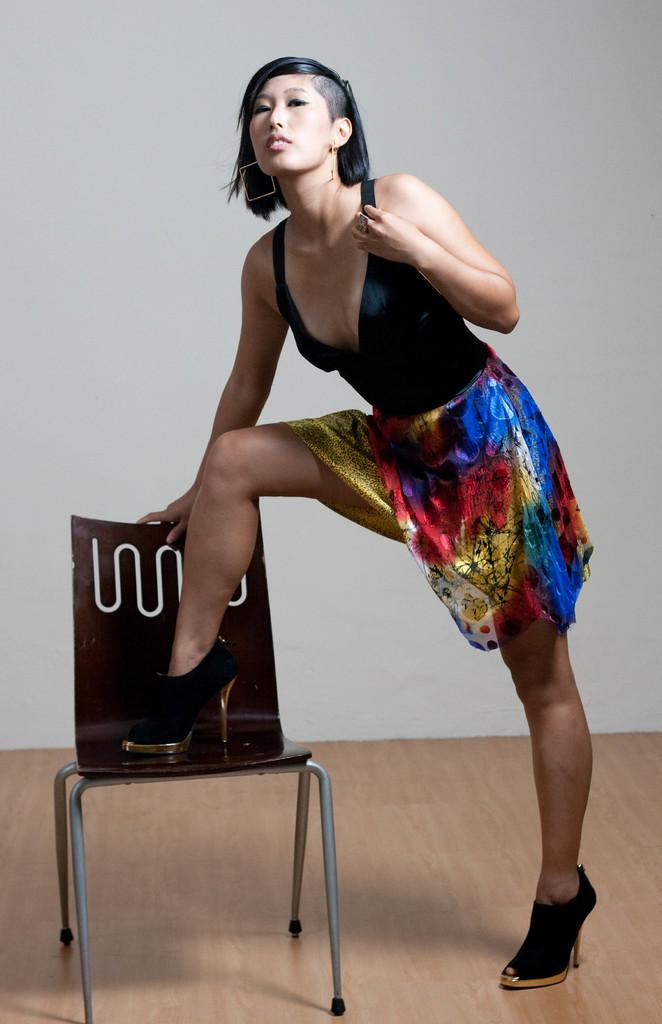What is the person in the image wearing? The person in the image is wearing a colorful dress. What type of footwear is the person wearing? The person is wearing footwear. What piece of furniture is present in the image? There is a chair in the image. What color is the wall in the background of the image? The wall in the background of the image is white. How does the stranger in the image increase the kitten's curiosity? There is no stranger or kitten present in the image. 